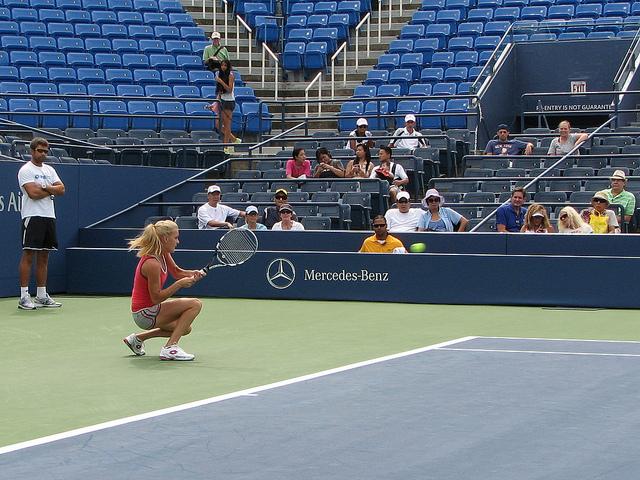What car company is on the side wall?
Answer briefly. Mercedes-benz. What car company logo is shown?
Quick response, please. Mercedes benz. Is the woman standing up straight?
Write a very short answer. No. Is this a practice or a game?
Short answer required. Game. Are there a lot of people in the stands?
Be succinct. No. What game are they playing?
Quick response, please. Tennis. Has she probably won this point?
Give a very brief answer. No. What type of shot is this tennis player performing?
Quick response, please. Backhand. 